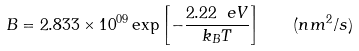Convert formula to latex. <formula><loc_0><loc_0><loc_500><loc_500>B = 2 . 8 3 3 \times 1 0 ^ { 0 9 } \exp \left [ { - \frac { 2 . 2 2 \ e V } { k _ { B } T } } \right ] \quad ( n m ^ { 2 } / s )</formula> 